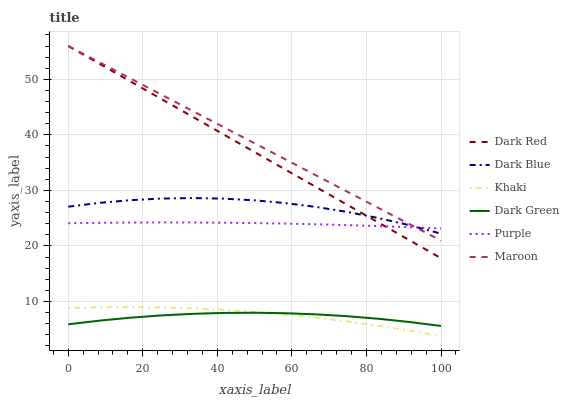Does Dark Green have the minimum area under the curve?
Answer yes or no. Yes. Does Maroon have the maximum area under the curve?
Answer yes or no. Yes. Does Purple have the minimum area under the curve?
Answer yes or no. No. Does Purple have the maximum area under the curve?
Answer yes or no. No. Is Maroon the smoothest?
Answer yes or no. Yes. Is Dark Blue the roughest?
Answer yes or no. Yes. Is Purple the smoothest?
Answer yes or no. No. Is Purple the roughest?
Answer yes or no. No. Does Khaki have the lowest value?
Answer yes or no. Yes. Does Dark Red have the lowest value?
Answer yes or no. No. Does Maroon have the highest value?
Answer yes or no. Yes. Does Purple have the highest value?
Answer yes or no. No. Is Dark Green less than Purple?
Answer yes or no. Yes. Is Dark Red greater than Dark Green?
Answer yes or no. Yes. Does Purple intersect Maroon?
Answer yes or no. Yes. Is Purple less than Maroon?
Answer yes or no. No. Is Purple greater than Maroon?
Answer yes or no. No. Does Dark Green intersect Purple?
Answer yes or no. No. 